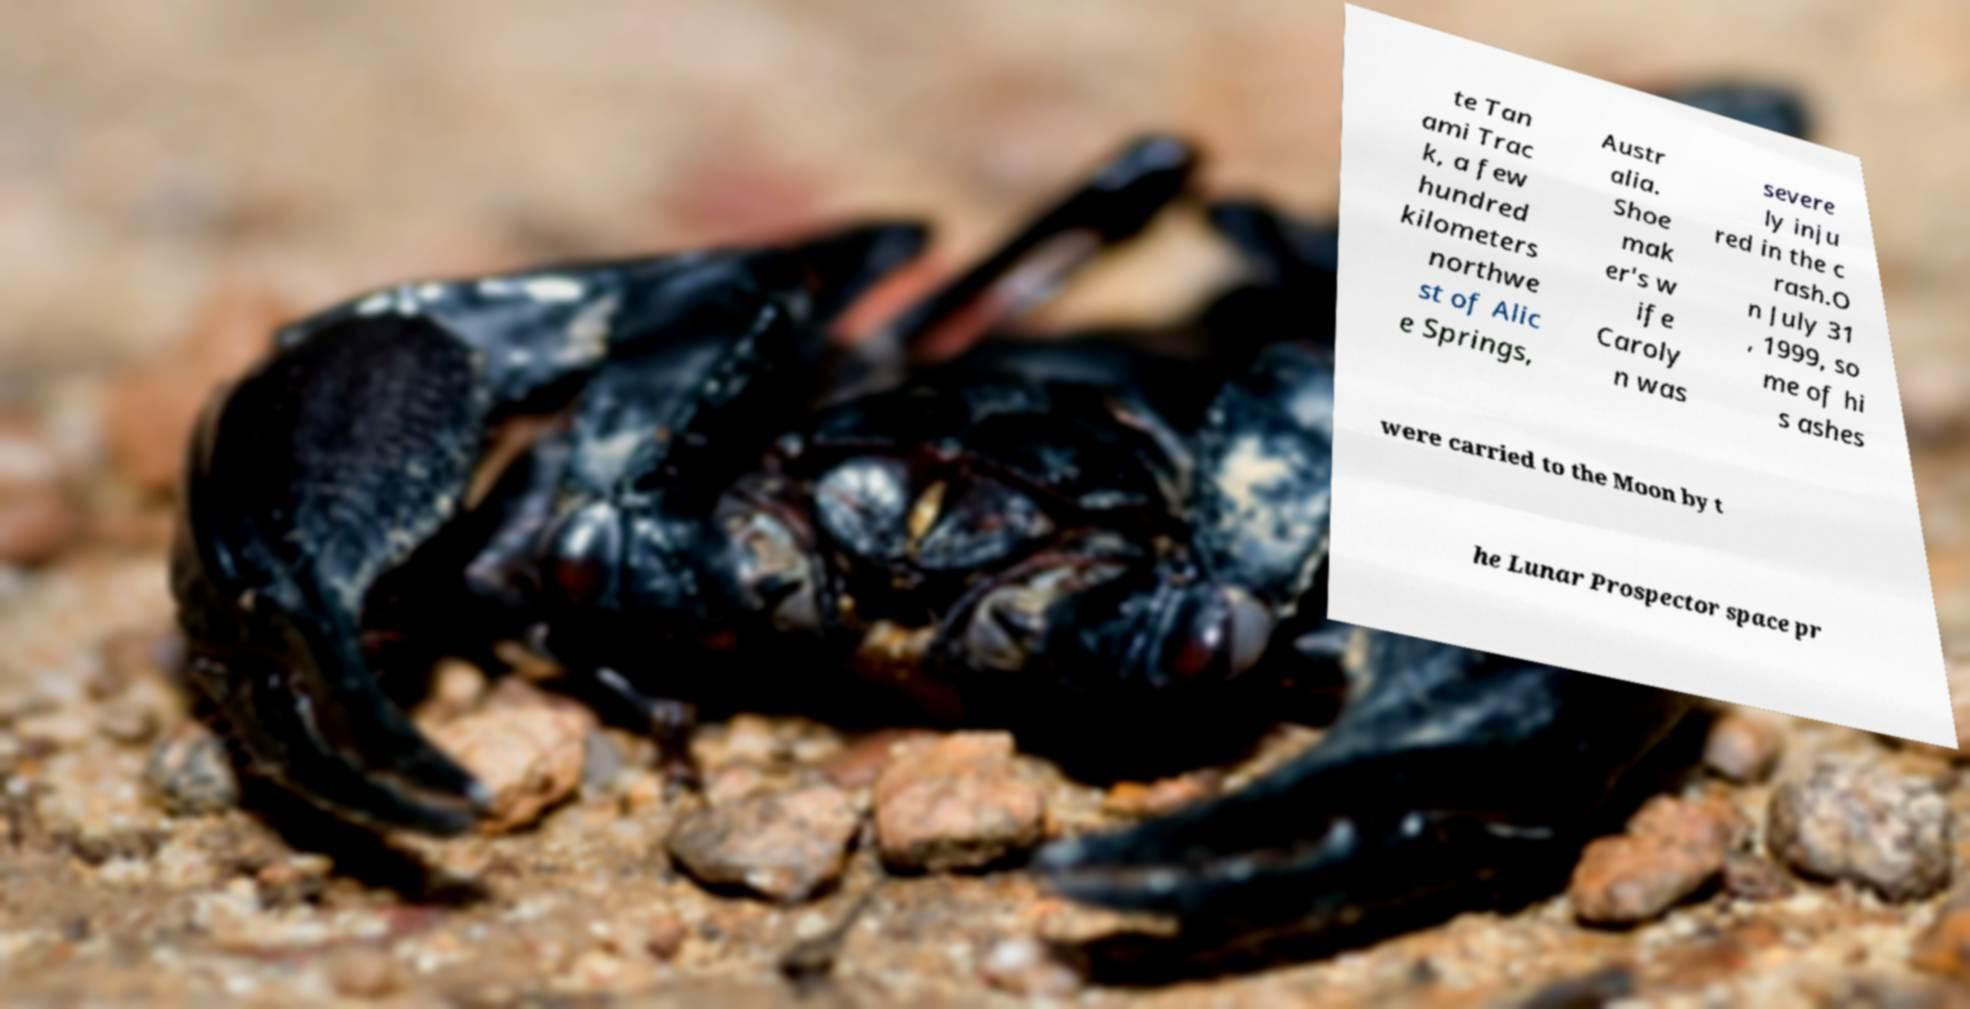Please read and relay the text visible in this image. What does it say? te Tan ami Trac k, a few hundred kilometers northwe st of Alic e Springs, Austr alia. Shoe mak er's w ife Caroly n was severe ly inju red in the c rash.O n July 31 , 1999, so me of hi s ashes were carried to the Moon by t he Lunar Prospector space pr 